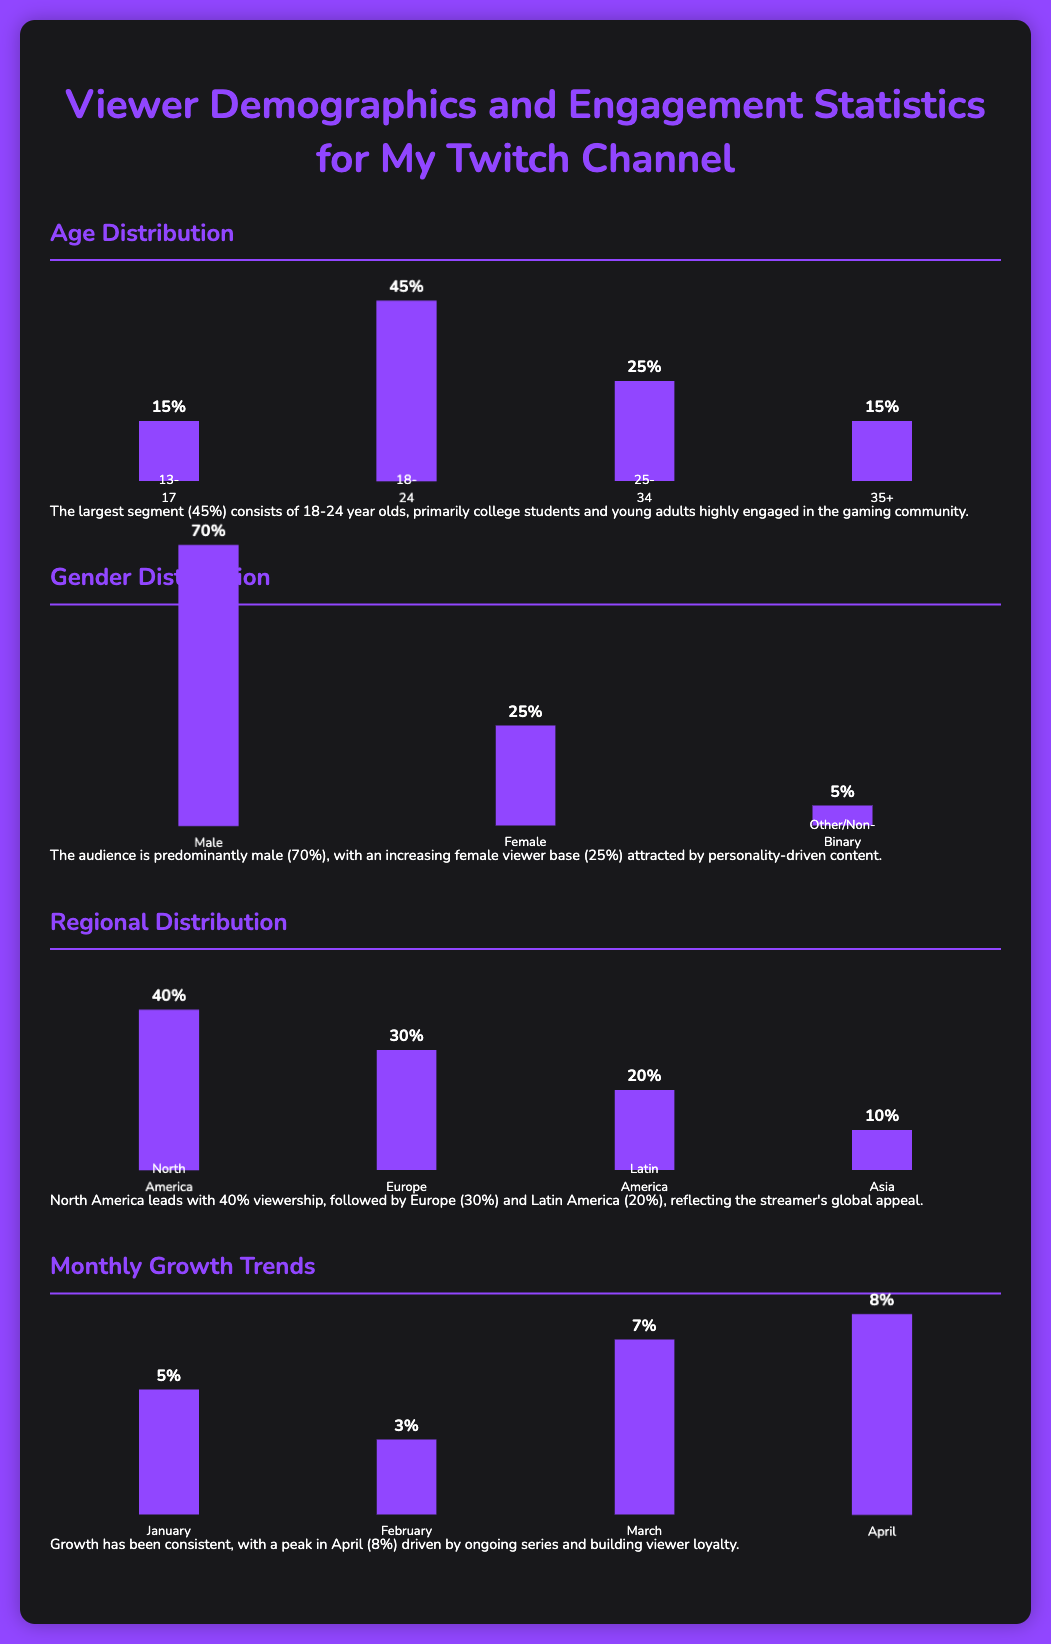What is the largest age group in the audience? The largest age group is indicated by the highest percentage in the Age Distribution section, which is 45% for ages 18-24.
Answer: 18-24 What percentage of viewers are female? The percentage of female viewers is directly stated in the Gender Distribution section, which shows 25%.
Answer: 25% Which region has the highest viewer percentage? The region with the highest viewer percentage is highlighted in the Regional Distribution section, with North America at 40%.
Answer: North America What was the percentage growth in April? The percentage growth for April is presented in the Monthly Growth Trends section, noted as 8%.
Answer: 8% How many viewers fall into the age category of 35 and older? The combined percentage for the age category of 35 and older is indicated in the Age Distribution section as 15%.
Answer: 15% Which gender has the lowest percentage of viewers? The lowest percentage of viewers is shown in the Gender Distribution section for Other/Non-Binary, which is 5%.
Answer: Other/Non-Binary What is the total percentage for the age group 25-34? The percentage for the age group 25-34 is given in the Age Distribution section as 25%.
Answer: 25% What was the growth percentage in March? The growth percentage in March is highlighted in the Monthly Growth Trends section, which is noted as 7%.
Answer: 7% Which month experienced the least growth? The month with the least growth is indicated in the Monthly Growth Trends section as February, with a growth rate of 3%.
Answer: February 